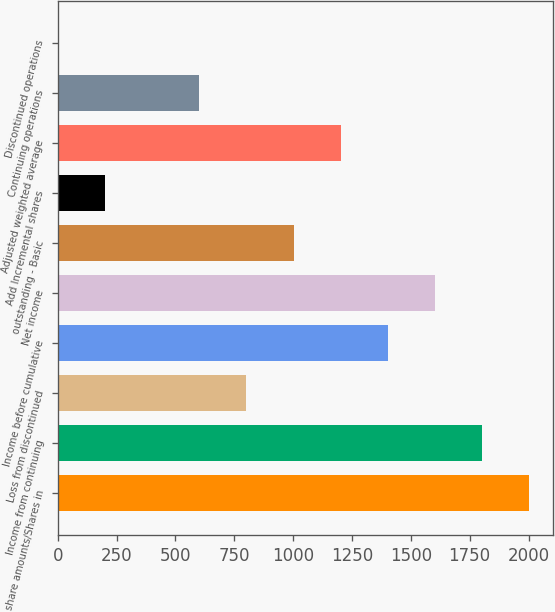<chart> <loc_0><loc_0><loc_500><loc_500><bar_chart><fcel>share amounts/Shares in<fcel>Income from continuing<fcel>Loss from discontinued<fcel>Income before cumulative<fcel>Net income<fcel>outstanding - Basic<fcel>Add Incremental shares<fcel>Adjusted weighted average<fcel>Continuing operations<fcel>Discontinued operations<nl><fcel>2004<fcel>1803.61<fcel>801.64<fcel>1402.82<fcel>1603.21<fcel>1002.03<fcel>200.45<fcel>1202.42<fcel>601.25<fcel>0.05<nl></chart> 